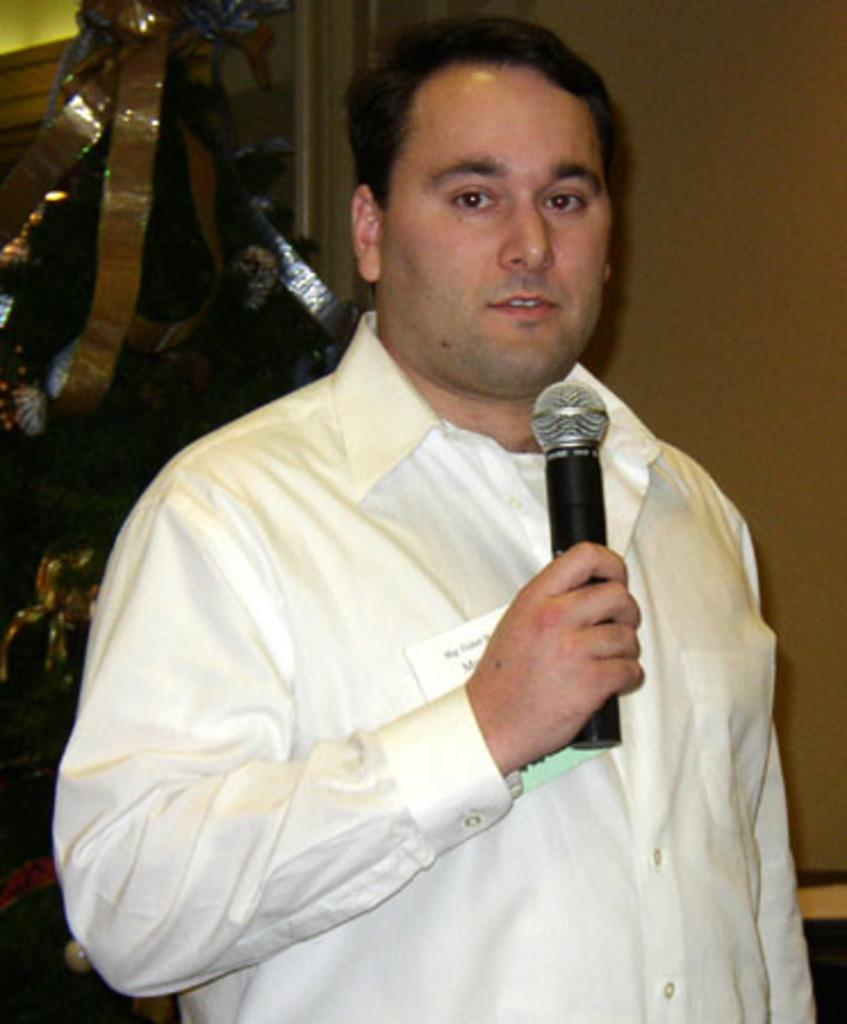What is the man in the image doing? The man is standing in the image and holding a microphone. What is the man wearing in the image? The man is wearing a shirt in the image. What can be seen on the wall in the background of the image? There is a paper visible on the wall in the background of the image. What type of material is visible in the image? Cloth is visible in the image. What type of drink is the man holding in the image? The man is not holding a drink in the image; he is holding a microphone. 